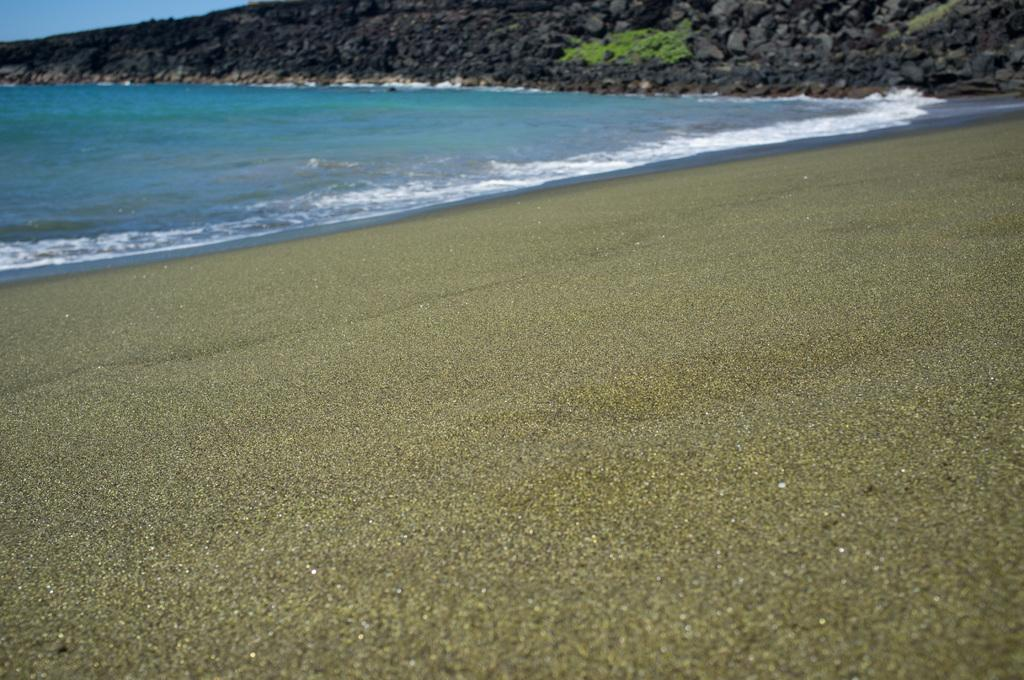What type of location is depicted in the image? The image contains a beach. What natural feature can be seen in the background of the image? There is an ocean visible in the image, specifically at the top. What type of tin can be seen on the beach in the image? There is no tin present on the beach in the image. 